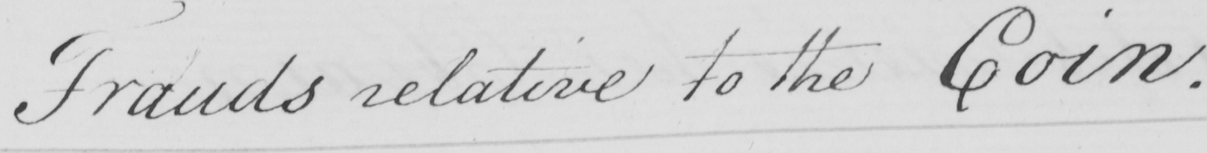Can you tell me what this handwritten text says? Frauds relative to the Coin . 